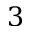<formula> <loc_0><loc_0><loc_500><loc_500>3</formula> 